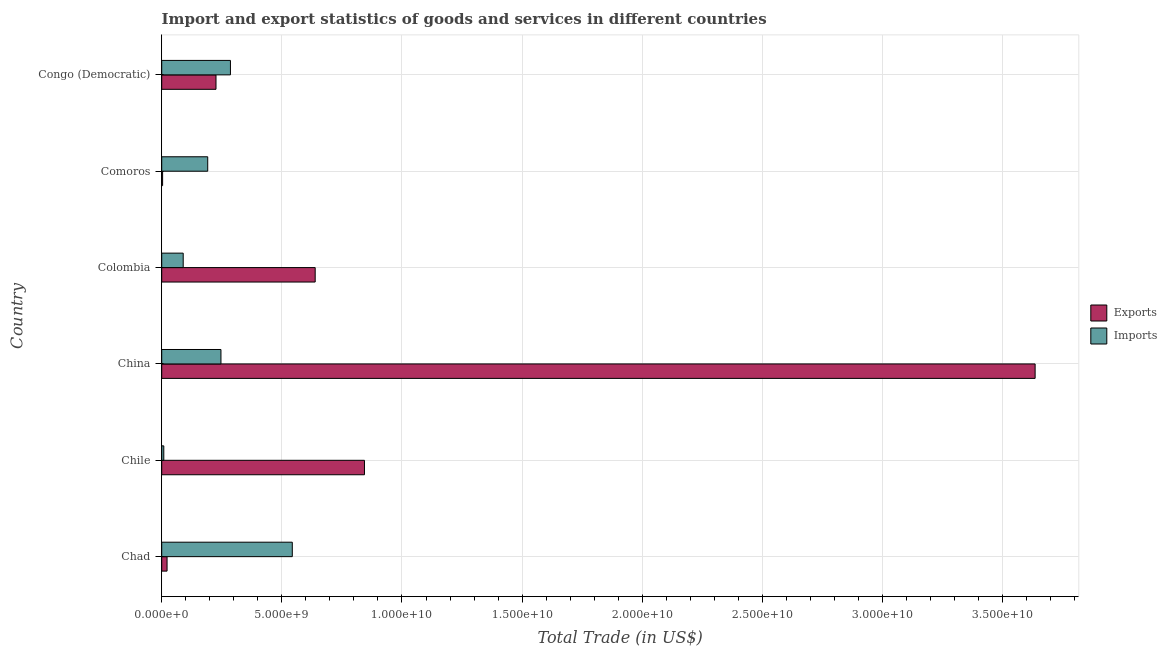How many different coloured bars are there?
Offer a very short reply. 2. How many groups of bars are there?
Make the answer very short. 6. Are the number of bars per tick equal to the number of legend labels?
Your response must be concise. Yes. Are the number of bars on each tick of the Y-axis equal?
Keep it short and to the point. Yes. How many bars are there on the 4th tick from the top?
Provide a succinct answer. 2. How many bars are there on the 4th tick from the bottom?
Your answer should be compact. 2. What is the label of the 5th group of bars from the top?
Ensure brevity in your answer.  Chile. In how many cases, is the number of bars for a given country not equal to the number of legend labels?
Your answer should be compact. 0. What is the export of goods and services in Comoros?
Offer a terse response. 3.73e+07. Across all countries, what is the maximum export of goods and services?
Provide a succinct answer. 3.64e+1. Across all countries, what is the minimum imports of goods and services?
Provide a short and direct response. 8.67e+07. In which country was the imports of goods and services maximum?
Your answer should be compact. Chad. What is the total imports of goods and services in the graph?
Provide a succinct answer. 1.37e+1. What is the difference between the imports of goods and services in China and that in Congo (Democratic)?
Ensure brevity in your answer.  -3.95e+08. What is the difference between the imports of goods and services in China and the export of goods and services in Comoros?
Keep it short and to the point. 2.43e+09. What is the average export of goods and services per country?
Keep it short and to the point. 8.95e+09. What is the difference between the imports of goods and services and export of goods and services in China?
Provide a succinct answer. -3.39e+1. In how many countries, is the imports of goods and services greater than 3000000000 US$?
Make the answer very short. 1. What is the ratio of the export of goods and services in Chile to that in Colombia?
Offer a very short reply. 1.32. Is the imports of goods and services in Chad less than that in Chile?
Keep it short and to the point. No. What is the difference between the highest and the second highest imports of goods and services?
Offer a very short reply. 2.57e+09. What is the difference between the highest and the lowest export of goods and services?
Your answer should be compact. 3.63e+1. What does the 2nd bar from the top in Chad represents?
Offer a very short reply. Exports. What does the 1st bar from the bottom in Chad represents?
Your response must be concise. Exports. How many bars are there?
Give a very brief answer. 12. What is the difference between two consecutive major ticks on the X-axis?
Offer a very short reply. 5.00e+09. Are the values on the major ticks of X-axis written in scientific E-notation?
Give a very brief answer. Yes. Does the graph contain any zero values?
Provide a succinct answer. No. Does the graph contain grids?
Offer a terse response. Yes. What is the title of the graph?
Ensure brevity in your answer.  Import and export statistics of goods and services in different countries. What is the label or title of the X-axis?
Give a very brief answer. Total Trade (in US$). What is the label or title of the Y-axis?
Offer a terse response. Country. What is the Total Trade (in US$) of Exports in Chad?
Your response must be concise. 2.23e+08. What is the Total Trade (in US$) of Imports in Chad?
Make the answer very short. 5.43e+09. What is the Total Trade (in US$) of Exports in Chile?
Provide a succinct answer. 8.44e+09. What is the Total Trade (in US$) of Imports in Chile?
Make the answer very short. 8.67e+07. What is the Total Trade (in US$) in Exports in China?
Your response must be concise. 3.64e+1. What is the Total Trade (in US$) of Imports in China?
Keep it short and to the point. 2.47e+09. What is the Total Trade (in US$) in Exports in Colombia?
Provide a succinct answer. 6.39e+09. What is the Total Trade (in US$) of Imports in Colombia?
Ensure brevity in your answer.  8.94e+08. What is the Total Trade (in US$) in Exports in Comoros?
Make the answer very short. 3.73e+07. What is the Total Trade (in US$) of Imports in Comoros?
Offer a terse response. 1.91e+09. What is the Total Trade (in US$) in Exports in Congo (Democratic)?
Provide a succinct answer. 2.26e+09. What is the Total Trade (in US$) in Imports in Congo (Democratic)?
Offer a terse response. 2.86e+09. Across all countries, what is the maximum Total Trade (in US$) of Exports?
Provide a succinct answer. 3.64e+1. Across all countries, what is the maximum Total Trade (in US$) of Imports?
Provide a short and direct response. 5.43e+09. Across all countries, what is the minimum Total Trade (in US$) of Exports?
Give a very brief answer. 3.73e+07. Across all countries, what is the minimum Total Trade (in US$) of Imports?
Your answer should be compact. 8.67e+07. What is the total Total Trade (in US$) of Exports in the graph?
Provide a short and direct response. 5.37e+1. What is the total Total Trade (in US$) in Imports in the graph?
Your response must be concise. 1.37e+1. What is the difference between the Total Trade (in US$) of Exports in Chad and that in Chile?
Provide a short and direct response. -8.22e+09. What is the difference between the Total Trade (in US$) of Imports in Chad and that in Chile?
Ensure brevity in your answer.  5.35e+09. What is the difference between the Total Trade (in US$) in Exports in Chad and that in China?
Your answer should be very brief. -3.61e+1. What is the difference between the Total Trade (in US$) in Imports in Chad and that in China?
Your answer should be very brief. 2.97e+09. What is the difference between the Total Trade (in US$) of Exports in Chad and that in Colombia?
Your answer should be compact. -6.16e+09. What is the difference between the Total Trade (in US$) in Imports in Chad and that in Colombia?
Make the answer very short. 4.54e+09. What is the difference between the Total Trade (in US$) of Exports in Chad and that in Comoros?
Keep it short and to the point. 1.85e+08. What is the difference between the Total Trade (in US$) of Imports in Chad and that in Comoros?
Ensure brevity in your answer.  3.52e+09. What is the difference between the Total Trade (in US$) in Exports in Chad and that in Congo (Democratic)?
Offer a very short reply. -2.04e+09. What is the difference between the Total Trade (in US$) in Imports in Chad and that in Congo (Democratic)?
Your answer should be very brief. 2.57e+09. What is the difference between the Total Trade (in US$) of Exports in Chile and that in China?
Provide a succinct answer. -2.79e+1. What is the difference between the Total Trade (in US$) of Imports in Chile and that in China?
Offer a very short reply. -2.38e+09. What is the difference between the Total Trade (in US$) of Exports in Chile and that in Colombia?
Your answer should be very brief. 2.05e+09. What is the difference between the Total Trade (in US$) of Imports in Chile and that in Colombia?
Your answer should be compact. -8.08e+08. What is the difference between the Total Trade (in US$) in Exports in Chile and that in Comoros?
Offer a very short reply. 8.40e+09. What is the difference between the Total Trade (in US$) of Imports in Chile and that in Comoros?
Your response must be concise. -1.83e+09. What is the difference between the Total Trade (in US$) of Exports in Chile and that in Congo (Democratic)?
Your response must be concise. 6.18e+09. What is the difference between the Total Trade (in US$) in Imports in Chile and that in Congo (Democratic)?
Provide a succinct answer. -2.77e+09. What is the difference between the Total Trade (in US$) in Exports in China and that in Colombia?
Your answer should be very brief. 3.00e+1. What is the difference between the Total Trade (in US$) in Imports in China and that in Colombia?
Provide a succinct answer. 1.57e+09. What is the difference between the Total Trade (in US$) of Exports in China and that in Comoros?
Your response must be concise. 3.63e+1. What is the difference between the Total Trade (in US$) in Imports in China and that in Comoros?
Provide a succinct answer. 5.51e+08. What is the difference between the Total Trade (in US$) in Exports in China and that in Congo (Democratic)?
Provide a succinct answer. 3.41e+1. What is the difference between the Total Trade (in US$) of Imports in China and that in Congo (Democratic)?
Offer a terse response. -3.95e+08. What is the difference between the Total Trade (in US$) of Exports in Colombia and that in Comoros?
Offer a terse response. 6.35e+09. What is the difference between the Total Trade (in US$) in Imports in Colombia and that in Comoros?
Keep it short and to the point. -1.02e+09. What is the difference between the Total Trade (in US$) of Exports in Colombia and that in Congo (Democratic)?
Your answer should be very brief. 4.13e+09. What is the difference between the Total Trade (in US$) in Imports in Colombia and that in Congo (Democratic)?
Make the answer very short. -1.97e+09. What is the difference between the Total Trade (in US$) of Exports in Comoros and that in Congo (Democratic)?
Your answer should be very brief. -2.22e+09. What is the difference between the Total Trade (in US$) of Imports in Comoros and that in Congo (Democratic)?
Provide a succinct answer. -9.46e+08. What is the difference between the Total Trade (in US$) of Exports in Chad and the Total Trade (in US$) of Imports in Chile?
Provide a succinct answer. 1.36e+08. What is the difference between the Total Trade (in US$) in Exports in Chad and the Total Trade (in US$) in Imports in China?
Keep it short and to the point. -2.24e+09. What is the difference between the Total Trade (in US$) of Exports in Chad and the Total Trade (in US$) of Imports in Colombia?
Ensure brevity in your answer.  -6.72e+08. What is the difference between the Total Trade (in US$) of Exports in Chad and the Total Trade (in US$) of Imports in Comoros?
Offer a very short reply. -1.69e+09. What is the difference between the Total Trade (in US$) of Exports in Chad and the Total Trade (in US$) of Imports in Congo (Democratic)?
Give a very brief answer. -2.64e+09. What is the difference between the Total Trade (in US$) in Exports in Chile and the Total Trade (in US$) in Imports in China?
Provide a short and direct response. 5.97e+09. What is the difference between the Total Trade (in US$) of Exports in Chile and the Total Trade (in US$) of Imports in Colombia?
Offer a very short reply. 7.54e+09. What is the difference between the Total Trade (in US$) in Exports in Chile and the Total Trade (in US$) in Imports in Comoros?
Your response must be concise. 6.52e+09. What is the difference between the Total Trade (in US$) in Exports in Chile and the Total Trade (in US$) in Imports in Congo (Democratic)?
Your answer should be compact. 5.58e+09. What is the difference between the Total Trade (in US$) of Exports in China and the Total Trade (in US$) of Imports in Colombia?
Ensure brevity in your answer.  3.55e+1. What is the difference between the Total Trade (in US$) in Exports in China and the Total Trade (in US$) in Imports in Comoros?
Provide a succinct answer. 3.44e+1. What is the difference between the Total Trade (in US$) of Exports in China and the Total Trade (in US$) of Imports in Congo (Democratic)?
Your answer should be compact. 3.35e+1. What is the difference between the Total Trade (in US$) of Exports in Colombia and the Total Trade (in US$) of Imports in Comoros?
Offer a very short reply. 4.47e+09. What is the difference between the Total Trade (in US$) of Exports in Colombia and the Total Trade (in US$) of Imports in Congo (Democratic)?
Ensure brevity in your answer.  3.53e+09. What is the difference between the Total Trade (in US$) of Exports in Comoros and the Total Trade (in US$) of Imports in Congo (Democratic)?
Provide a succinct answer. -2.82e+09. What is the average Total Trade (in US$) in Exports per country?
Keep it short and to the point. 8.95e+09. What is the average Total Trade (in US$) of Imports per country?
Offer a very short reply. 2.28e+09. What is the difference between the Total Trade (in US$) in Exports and Total Trade (in US$) in Imports in Chad?
Provide a short and direct response. -5.21e+09. What is the difference between the Total Trade (in US$) in Exports and Total Trade (in US$) in Imports in Chile?
Provide a succinct answer. 8.35e+09. What is the difference between the Total Trade (in US$) in Exports and Total Trade (in US$) in Imports in China?
Your answer should be very brief. 3.39e+1. What is the difference between the Total Trade (in US$) in Exports and Total Trade (in US$) in Imports in Colombia?
Keep it short and to the point. 5.49e+09. What is the difference between the Total Trade (in US$) in Exports and Total Trade (in US$) in Imports in Comoros?
Your answer should be very brief. -1.88e+09. What is the difference between the Total Trade (in US$) of Exports and Total Trade (in US$) of Imports in Congo (Democratic)?
Make the answer very short. -6.01e+08. What is the ratio of the Total Trade (in US$) of Exports in Chad to that in Chile?
Your response must be concise. 0.03. What is the ratio of the Total Trade (in US$) in Imports in Chad to that in Chile?
Ensure brevity in your answer.  62.71. What is the ratio of the Total Trade (in US$) of Exports in Chad to that in China?
Keep it short and to the point. 0.01. What is the ratio of the Total Trade (in US$) of Imports in Chad to that in China?
Offer a terse response. 2.2. What is the ratio of the Total Trade (in US$) of Exports in Chad to that in Colombia?
Keep it short and to the point. 0.03. What is the ratio of the Total Trade (in US$) in Imports in Chad to that in Colombia?
Provide a succinct answer. 6.08. What is the ratio of the Total Trade (in US$) in Exports in Chad to that in Comoros?
Ensure brevity in your answer.  5.97. What is the ratio of the Total Trade (in US$) of Imports in Chad to that in Comoros?
Your answer should be very brief. 2.84. What is the ratio of the Total Trade (in US$) in Exports in Chad to that in Congo (Democratic)?
Your answer should be very brief. 0.1. What is the ratio of the Total Trade (in US$) in Imports in Chad to that in Congo (Democratic)?
Ensure brevity in your answer.  1.9. What is the ratio of the Total Trade (in US$) of Exports in Chile to that in China?
Offer a very short reply. 0.23. What is the ratio of the Total Trade (in US$) in Imports in Chile to that in China?
Offer a terse response. 0.04. What is the ratio of the Total Trade (in US$) in Exports in Chile to that in Colombia?
Offer a terse response. 1.32. What is the ratio of the Total Trade (in US$) of Imports in Chile to that in Colombia?
Provide a short and direct response. 0.1. What is the ratio of the Total Trade (in US$) of Exports in Chile to that in Comoros?
Your answer should be very brief. 226.16. What is the ratio of the Total Trade (in US$) in Imports in Chile to that in Comoros?
Give a very brief answer. 0.05. What is the ratio of the Total Trade (in US$) of Exports in Chile to that in Congo (Democratic)?
Keep it short and to the point. 3.73. What is the ratio of the Total Trade (in US$) of Imports in Chile to that in Congo (Democratic)?
Make the answer very short. 0.03. What is the ratio of the Total Trade (in US$) in Exports in China to that in Colombia?
Make the answer very short. 5.69. What is the ratio of the Total Trade (in US$) of Imports in China to that in Colombia?
Ensure brevity in your answer.  2.76. What is the ratio of the Total Trade (in US$) in Exports in China to that in Comoros?
Your answer should be very brief. 974.2. What is the ratio of the Total Trade (in US$) of Imports in China to that in Comoros?
Make the answer very short. 1.29. What is the ratio of the Total Trade (in US$) of Exports in China to that in Congo (Democratic)?
Your answer should be very brief. 16.09. What is the ratio of the Total Trade (in US$) in Imports in China to that in Congo (Democratic)?
Offer a terse response. 0.86. What is the ratio of the Total Trade (in US$) in Exports in Colombia to that in Comoros?
Offer a terse response. 171.18. What is the ratio of the Total Trade (in US$) in Imports in Colombia to that in Comoros?
Your response must be concise. 0.47. What is the ratio of the Total Trade (in US$) of Exports in Colombia to that in Congo (Democratic)?
Provide a succinct answer. 2.83. What is the ratio of the Total Trade (in US$) of Imports in Colombia to that in Congo (Democratic)?
Your response must be concise. 0.31. What is the ratio of the Total Trade (in US$) of Exports in Comoros to that in Congo (Democratic)?
Keep it short and to the point. 0.02. What is the ratio of the Total Trade (in US$) in Imports in Comoros to that in Congo (Democratic)?
Provide a short and direct response. 0.67. What is the difference between the highest and the second highest Total Trade (in US$) in Exports?
Ensure brevity in your answer.  2.79e+1. What is the difference between the highest and the second highest Total Trade (in US$) in Imports?
Offer a terse response. 2.57e+09. What is the difference between the highest and the lowest Total Trade (in US$) in Exports?
Offer a terse response. 3.63e+1. What is the difference between the highest and the lowest Total Trade (in US$) in Imports?
Provide a short and direct response. 5.35e+09. 